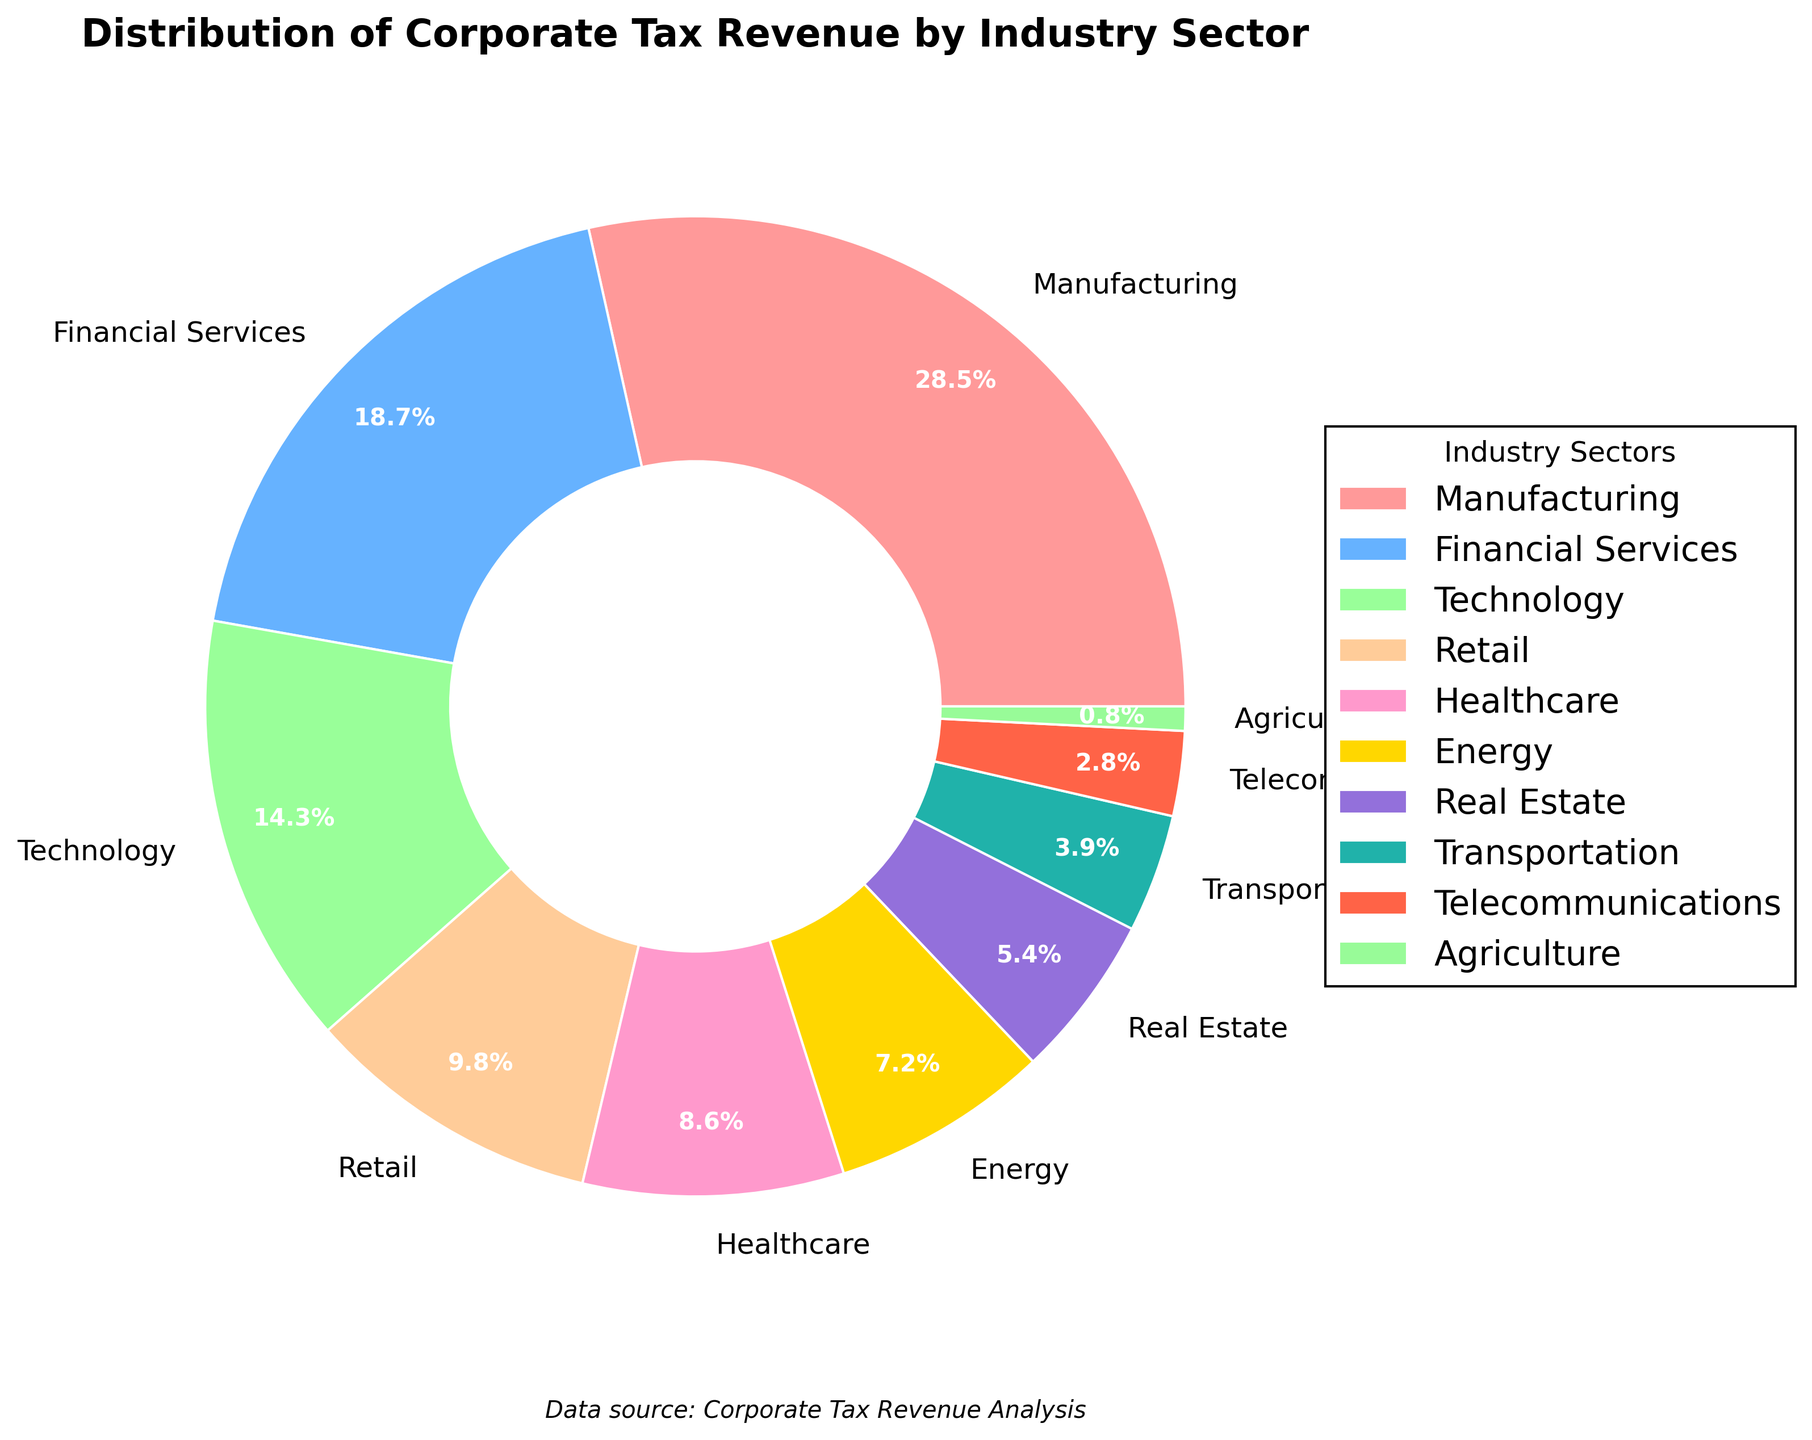What industry sector has the highest percentage of corporate tax revenue? Look at the wedges of the pie chart and identify the one with the largest size. The corresponding label will be the industry sector with the highest percentage of corporate tax revenue.
Answer: Manufacturing Which industry sector contributes the least to corporate tax revenue? Locate the smallest wedge in the pie chart. The label next to this wedge indicates the industry sector with the least corporate tax revenue.
Answer: Agriculture What is the combined percentage of corporate tax revenue for Financial Services and Technology? Locate the wedges and percentage values for Financial Services (18.7%) and Technology (14.3%). Add these percentages: 18.7% + 14.3% = 33.0%.
Answer: 33.0% How much more does the Manufacturing sector contribute to corporate tax revenue compared to the Retail sector? Find the values for Manufacturing (28.5%) and Retail (9.8%). Subtract Retail from Manufacturing: 28.5% - 9.8% = 18.7%.
Answer: 18.7% What is the average percentage of corporate tax revenue for Healthcare, Energy, and Real Estate? Locate the percentages for Healthcare (8.6%), Energy (7.2%), and Real Estate (5.4%). Add these values: 8.6% + 7.2% + 5.4% = 21.2%. Divide by 3 to find the average: 21.2% / 3 ≈ 7.07%.
Answer: 7.07% Which industry sectors contribute more than 10% to corporate tax revenue? Identify the wedges with percentages greater than 10%. The corresponding labels are the industry sectors contributing more than 10%. These are Manufacturing (28.5%), Financial Services (18.7%), and Technology (14.3%).
Answer: Manufacturing, Financial Services, Technology How does the contribution of the Transportation sector compare to the Real Estate sector? Find the percentage values for Transportation (3.9%) and Real Estate (5.4%). Compare the two percentages: 3.9% is less than 5.4%.
Answer: Transportation contributes less than Real Estate If you combine the percentages of Retail, Healthcare, and Telecommunications, do they surpass the Manufacturing sector’s contribution? Add the values for Retail (9.8%), Healthcare (8.6%), and Telecommunications (2.8%). The sum is: 9.8% + 8.6% + 2.8% = 21.2%, which is less than Manufacturing's 28.5%.
Answer: No Which color is used to represent the Retail sector, and how is it visually indicated? Look for the wedge labeled Retail and note its color. Identify the visual attributes such as edge color for indication. Retail is labeled in a peach-like color (#FFCC99) with a white edge.
Answer: Peach-like color with a white edge What industry sectors fall into the bottom three positions in terms of corporate tax revenue contribution? Identify and list the three smallest wedges by percentage. These sectors are Telecommunications (2.8%), Transportation (3.9%), and Agriculture (0.8%).
Answer: Telecommunications, Transportation, Agriculture 